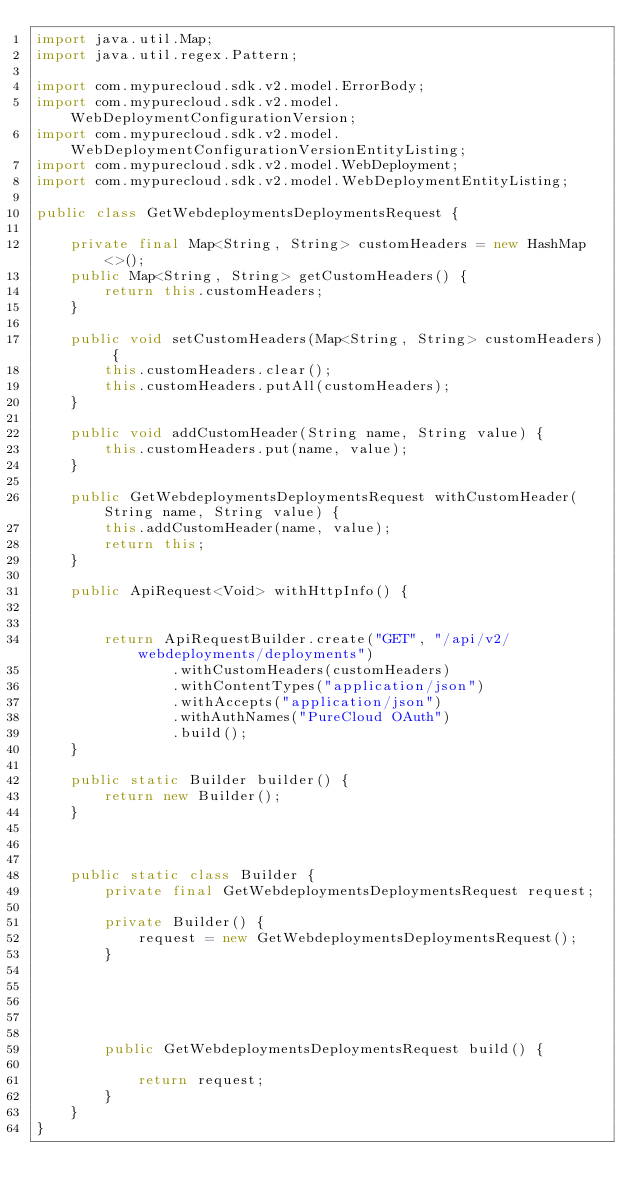<code> <loc_0><loc_0><loc_500><loc_500><_Java_>import java.util.Map;
import java.util.regex.Pattern;

import com.mypurecloud.sdk.v2.model.ErrorBody;
import com.mypurecloud.sdk.v2.model.WebDeploymentConfigurationVersion;
import com.mypurecloud.sdk.v2.model.WebDeploymentConfigurationVersionEntityListing;
import com.mypurecloud.sdk.v2.model.WebDeployment;
import com.mypurecloud.sdk.v2.model.WebDeploymentEntityListing;

public class GetWebdeploymentsDeploymentsRequest {
    
	private final Map<String, String> customHeaders = new HashMap<>();
    public Map<String, String> getCustomHeaders() {
        return this.customHeaders;
    }

    public void setCustomHeaders(Map<String, String> customHeaders) {
        this.customHeaders.clear();
        this.customHeaders.putAll(customHeaders);
    }

    public void addCustomHeader(String name, String value) {
        this.customHeaders.put(name, value);
    }

    public GetWebdeploymentsDeploymentsRequest withCustomHeader(String name, String value) {
        this.addCustomHeader(name, value);
        return this;
    }

    public ApiRequest<Void> withHttpInfo() {
        

        return ApiRequestBuilder.create("GET", "/api/v2/webdeployments/deployments")
                .withCustomHeaders(customHeaders)
                .withContentTypes("application/json")
                .withAccepts("application/json")
                .withAuthNames("PureCloud OAuth")
                .build();
    }

	public static Builder builder() {
		return new Builder();
	}

	

	public static class Builder {
		private final GetWebdeploymentsDeploymentsRequest request;

		private Builder() {
			request = new GetWebdeploymentsDeploymentsRequest();
		}

		

		

		public GetWebdeploymentsDeploymentsRequest build() {
            
			return request;
		}
	}
}
</code> 